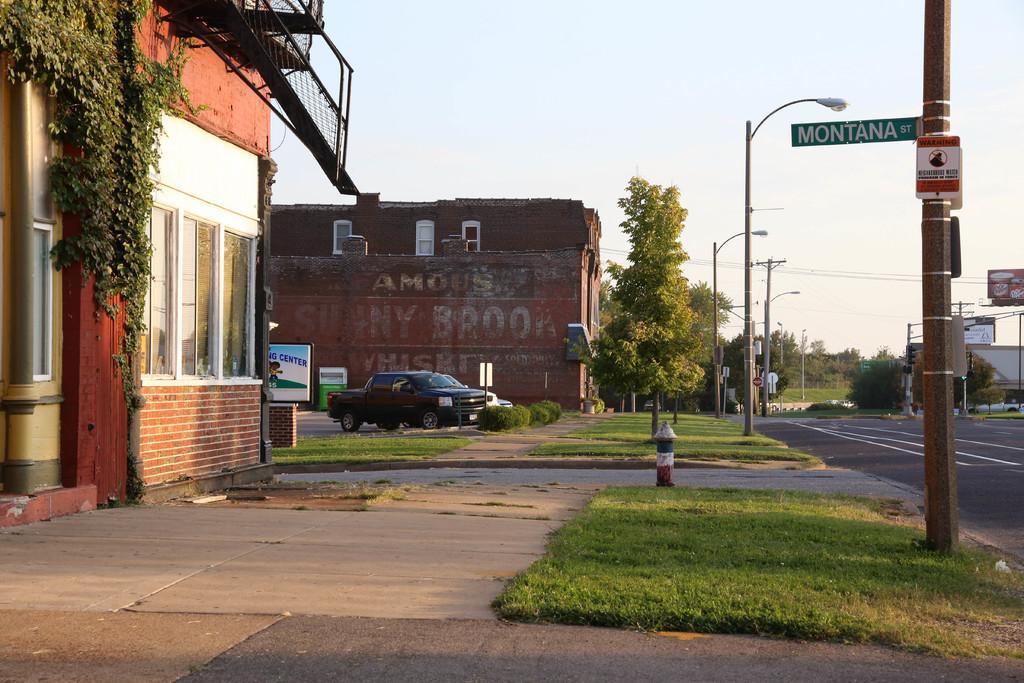Can you describe this image briefly? This image is taken outdoors. At the bottom of the image there is a floor and there is a ground with grass on it. On the left side of the image there are two houses with walls, windows, roofs and doors. There is a railing. There is a creeper with green leaves. There are two boards with text on them. Two cars are parked on the ground. In the middle of the image there are a few trees. There are a few pose with street lights and there is a sign board with a text on it. On the right side of the image there are a few trees. There are two boards with text on them. There are a few poles and there is a road. 